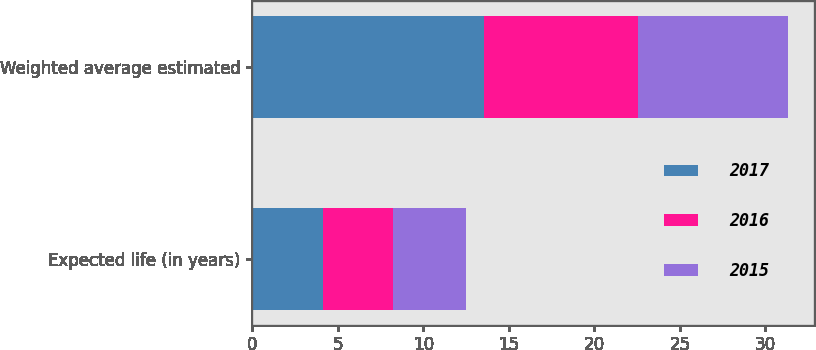<chart> <loc_0><loc_0><loc_500><loc_500><stacked_bar_chart><ecel><fcel>Expected life (in years)<fcel>Weighted average estimated<nl><fcel>2017<fcel>4.1<fcel>13.56<nl><fcel>2016<fcel>4.1<fcel>8.97<nl><fcel>2015<fcel>4.3<fcel>8.77<nl></chart> 